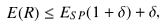Convert formula to latex. <formula><loc_0><loc_0><loc_500><loc_500>E ( R ) \leq E _ { S P } ( 1 + \delta ) + \delta ,</formula> 